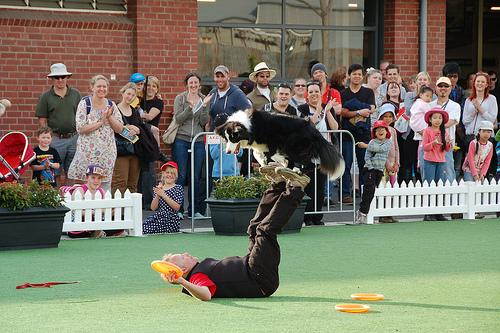How many frisbees can be seen in the image, and where are they located? There are 5 frisbees; 3 on the ground, 1 in the man's right hand, and 1 yellow frisbee in hand. What are the additional items around the man performing tricks with the dog? There is a window on the building, a stroller by the plants, and a pot with a plant in it. Can you describe the appearance of the dog in the image? The dog appears to be black in color and has a visible tail. How many people are watching the man perform tricks with the dog? There seem to be 9 other people watching the man perform tricks with the dog. State the sentiment evoked by the image. The sentiment is positive and exciting, as people watch a man perform tricks with a dog. Describe the fencing structure that can be seen near the people. A small fence is seen near the people, located on the lawn with a width of 135 and height of 135. Is the quality of the image satisfactory for object detection and interaction analysis? Yes, the quality is sufficient for object detection and interaction analysis. What is the man doing with the dog in the image? The man is lifting the dog up and doing frisbee tricks with it. Mention the objects on the ground that are related to the man's activity. Frisbees are on the ground as the man performs tricks with the dog. List the people present in the image, along with their clothing or accessories. 8. Guy with a hat Describe the scene in the image. A man is doing frisbee tricks with a dog, while people watch. There are frisbees on the ground, a fence nearby, and multiple hat-wearers. Is there a stroller in the image? If so, provide its location and size. Yes, at X:1, Y:132, Width:35, Height:35 Are there any anomalies in the image? No What type of plants are present in the pot? Not specified What are the left-top corner coordinates of the woman wearing a dress? X:68, Y:96 List all the objects detected in the image. Dog, frisbees, fence, man lifting dog, woman, girl, stroller, kid, hats, green shirt, pants, shoes, pot with plant, window Describe where the frisbee is in the man's hand. X:148, Y:258, Width:37, Height:37 What is the sentiment expressed by the scene in the image? Positive or Exciting Describe the position and size of the image of a girl wearing a red hat. X:162, Y:162, Width:14, Height:14 What color is the dog that is being lifted up? Black Where can you find the small fence in the image? Near the people, with left-top corner coordinates X:364, Y:178 Identify the location and dimensions of the man doing frisbee tricks with the dog. X:141, Y:102, Width:208, Height:208 Rate the image quality on a scale of 1 to 10, with 10 being the best. Subjective, but it could be around 7. What are the left-top corner coordinates and dimensions for the window on the building? X:198, Y:4, Width:183, Height:183 Are any of the viewers wearing a gray hat? Yes, at X:308, Y:62 Locate the red hat on the girl in terms of position and dimensions. X:142, Y:160, Width:42, Height:42 Identify the objects interacting with each other in the image. Man and dog, man and frisbee What type of clothing item is present on the man at X:196, Y:255? Vest Among the viewers, who is wearing a pink t-shirt? Girl at X:420, Y:105 What color is the frisbee on the ground near X:333, Y:301? Yellow 